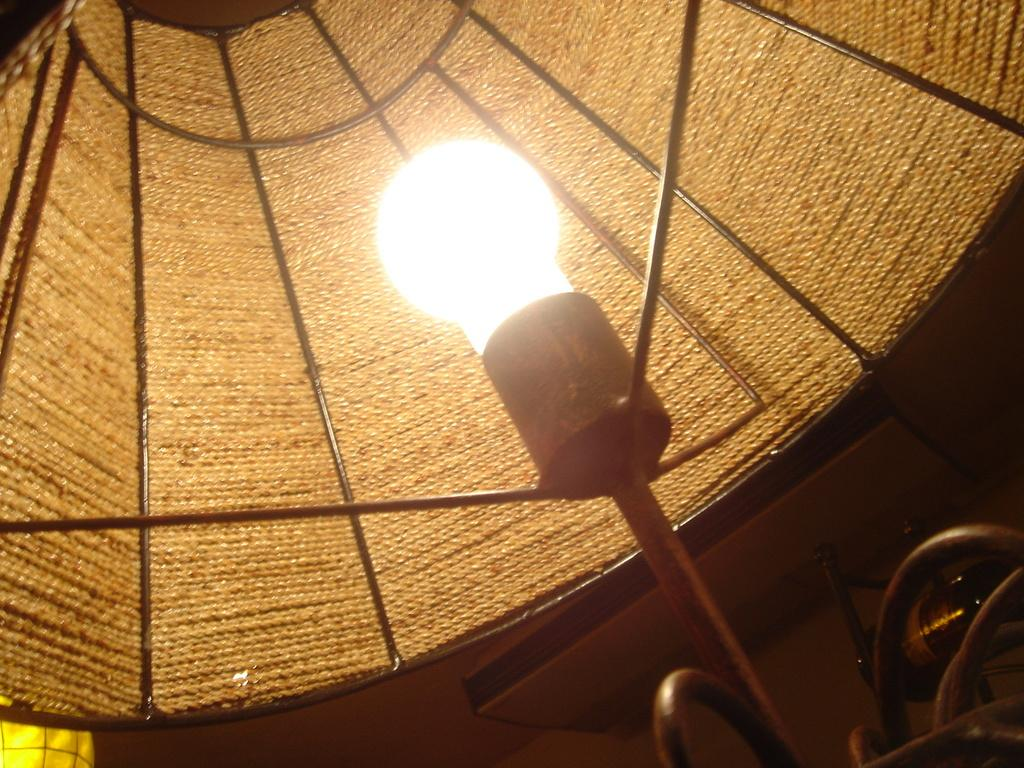What type of lighting fixture is present in the image? There is a lamp in the image. What color is the object on the right side of the image? There is a yellow object in the image. Can you describe the objects on the right side of the image? There are a few objects on the right side of the image. How many apples are hanging from the wrist of the person in the image? There is no person or apple present in the image. What type of pull-up exercise is being performed in the image? There is no exercise or person performing an exercise in the image. 